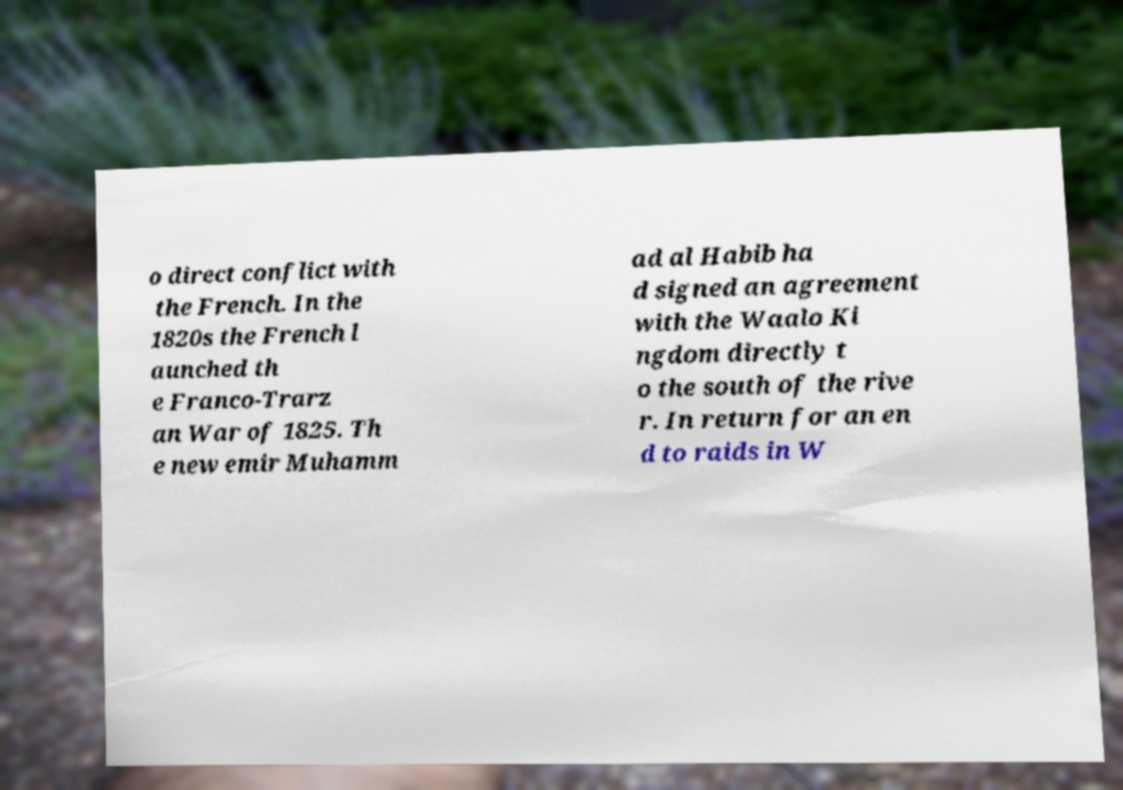What messages or text are displayed in this image? I need them in a readable, typed format. o direct conflict with the French. In the 1820s the French l aunched th e Franco-Trarz an War of 1825. Th e new emir Muhamm ad al Habib ha d signed an agreement with the Waalo Ki ngdom directly t o the south of the rive r. In return for an en d to raids in W 